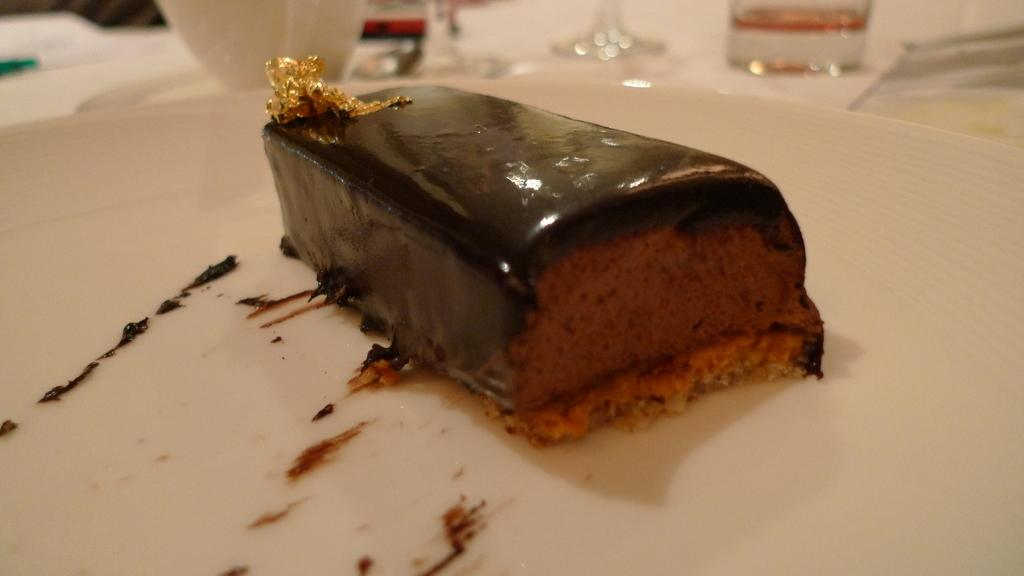What is the main food item served on the plate in the image? There is a dessert served on a plate in the image. What type of beverage container is beside the plate? There is a glass beside the plate in the image. What other objects can be seen beside the plate? There are other objects beside the plate in the image. What type of acoustics can be heard from the dessert in the image? There is no acoustics associated with the dessert in the image, as it is a visual representation and not a sound. 